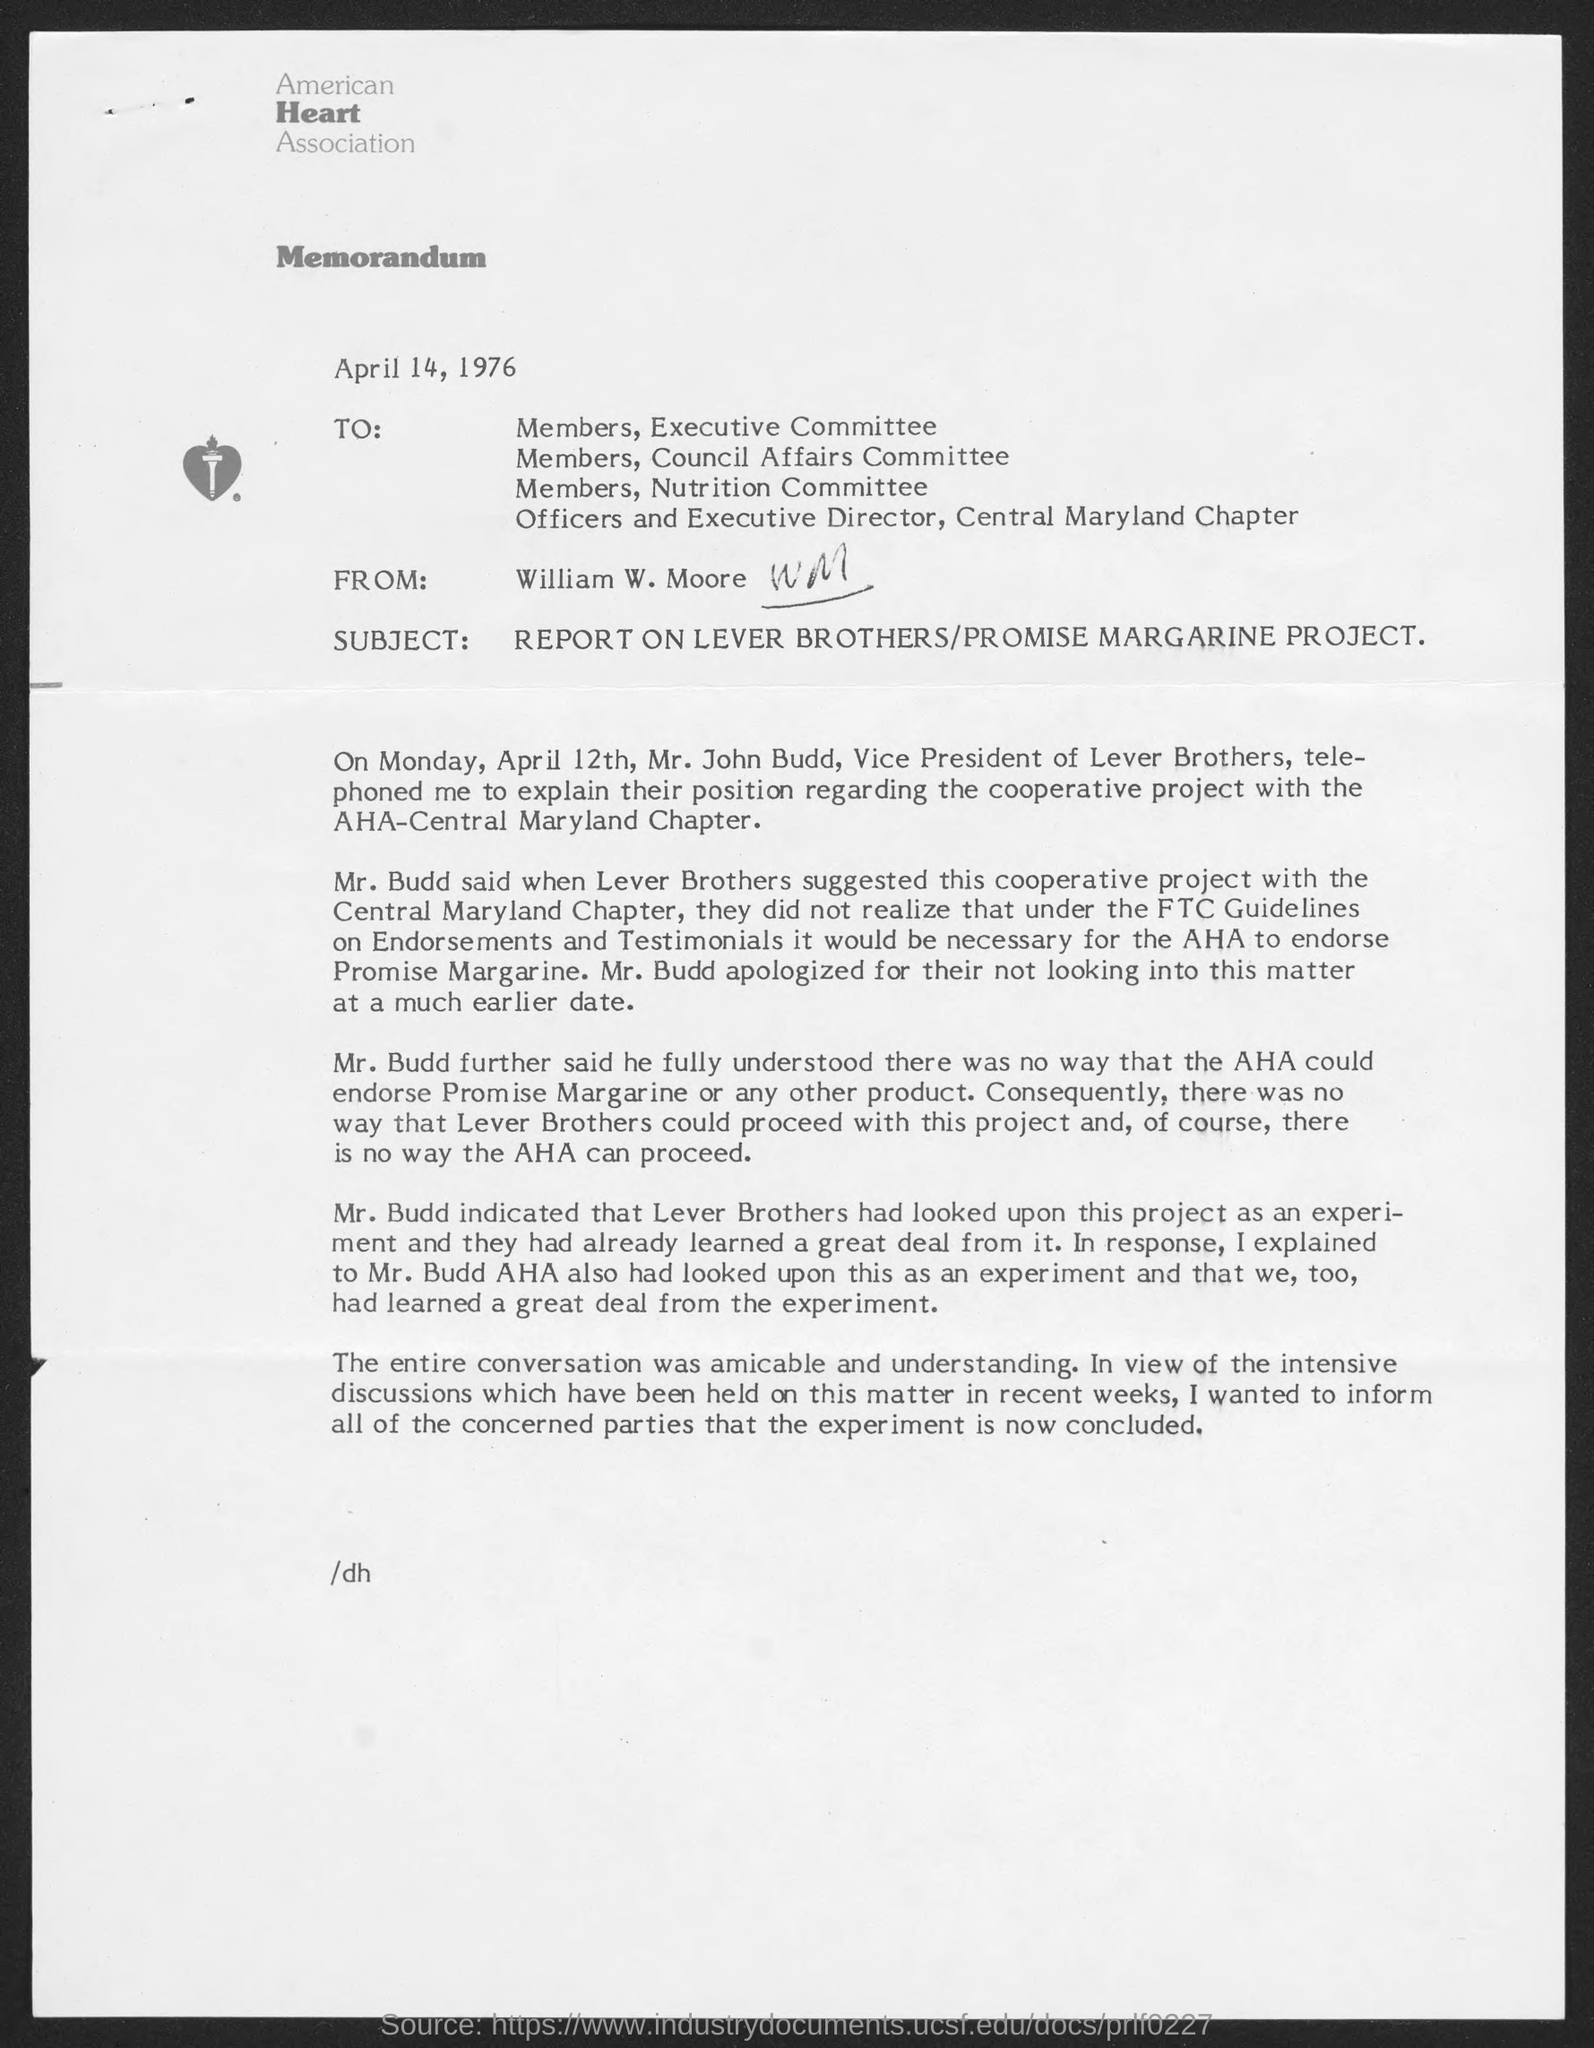Outline some significant characteristics in this image. The American Heart Association is the name of the association. The memorandum was written by William W. Moore. AHA stands for American Heart Association. 